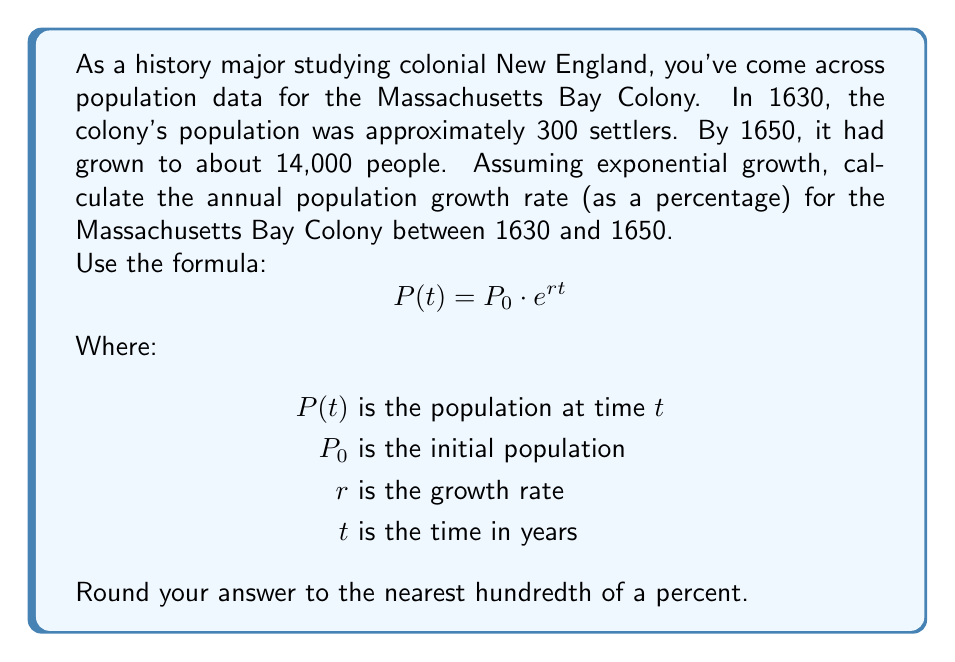Could you help me with this problem? To solve this problem, we'll use the exponential growth formula and logarithms. Let's break it down step-by-step:

1) We know:
   $P_0 = 300$ (initial population in 1630)
   $P(t) = 14000$ (population in 1650)
   $t = 20$ years (from 1630 to 1650)

2) We need to find $r$. Let's substitute these values into the formula:
   $$14000 = 300 \cdot e^{r \cdot 20}$$

3) Divide both sides by 300:
   $$\frac{14000}{300} = e^{r \cdot 20}$$

4) Simplify:
   $$46.67 = e^{20r}$$

5) Take the natural logarithm of both sides:
   $$\ln(46.67) = \ln(e^{20r})$$

6) Simplify the right side using the logarithm property $\ln(e^x) = x$:
   $$\ln(46.67) = 20r$$

7) Solve for $r$:
   $$r = \frac{\ln(46.67)}{20}$$

8) Calculate:
   $$r = \frac{3.8431}{20} = 0.1922$$

9) Convert to a percentage by multiplying by 100:
   $$0.1922 \cdot 100 = 19.22\%$$

10) Rounding to the nearest hundredth of a percent:
    $$19.22\%$$
Answer: The annual population growth rate for the Massachusetts Bay Colony between 1630 and 1650 was approximately 19.22%. 